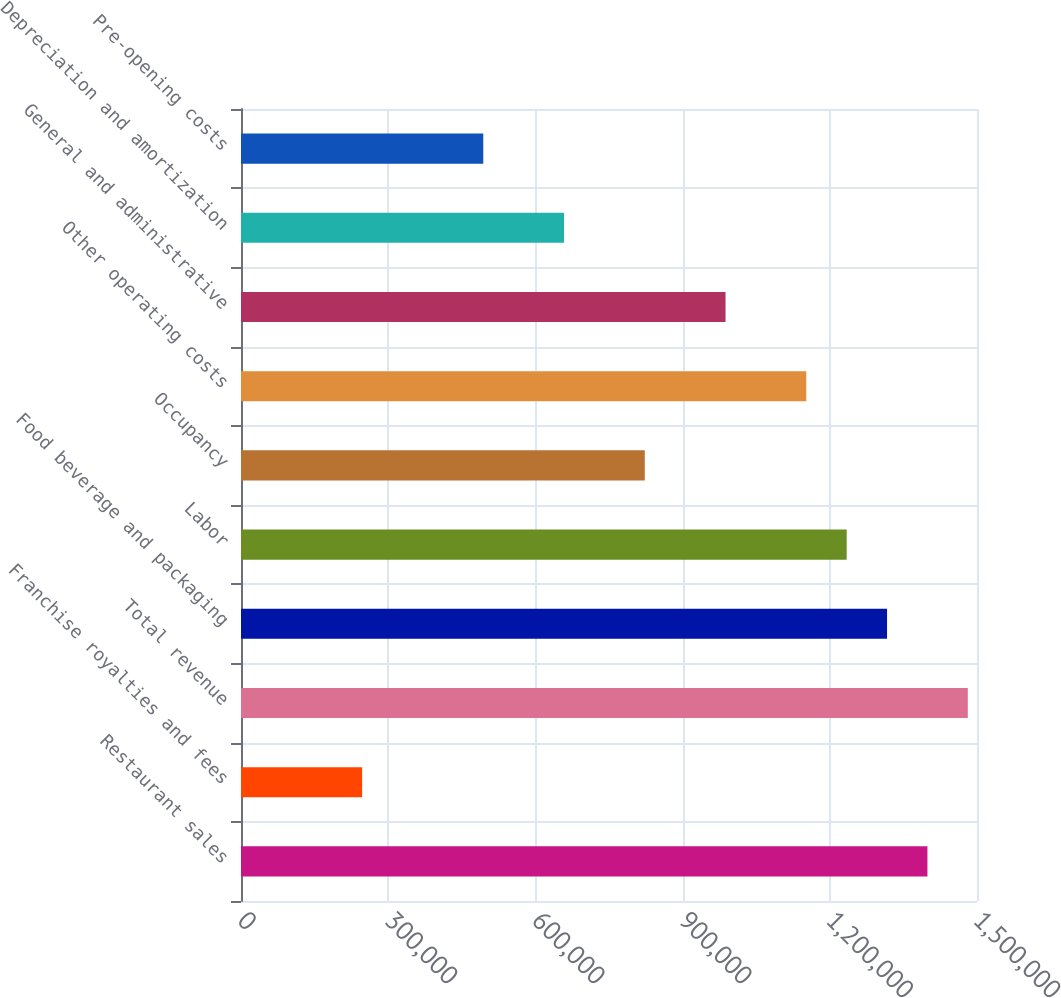Convert chart to OTSL. <chart><loc_0><loc_0><loc_500><loc_500><bar_chart><fcel>Restaurant sales<fcel>Franchise royalties and fees<fcel>Total revenue<fcel>Food beverage and packaging<fcel>Labor<fcel>Occupancy<fcel>Other operating costs<fcel>General and administrative<fcel>Depreciation and amortization<fcel>Pre-opening costs<nl><fcel>1.39898e+06<fcel>246880<fcel>1.48127e+06<fcel>1.31669e+06<fcel>1.23439e+06<fcel>822930<fcel>1.1521e+06<fcel>987516<fcel>658344<fcel>493758<nl></chart> 